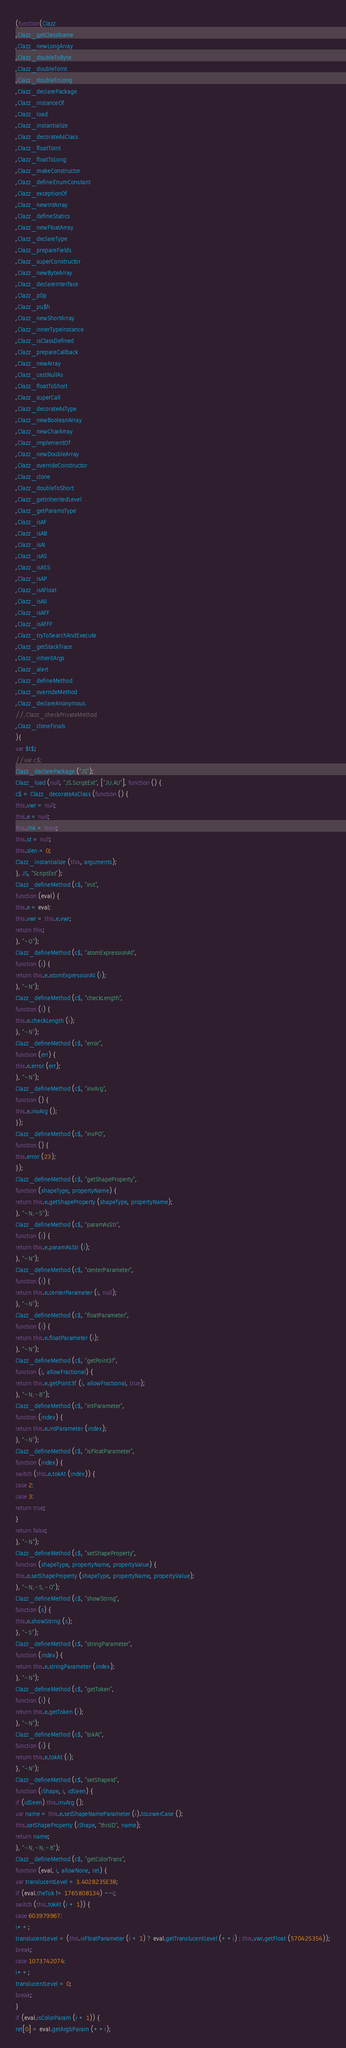Convert code to text. <code><loc_0><loc_0><loc_500><loc_500><_JavaScript_>(function(Clazz
,Clazz_getClassName
,Clazz_newLongArray
,Clazz_doubleToByte
,Clazz_doubleToInt
,Clazz_doubleToLong
,Clazz_declarePackage
,Clazz_instanceOf
,Clazz_load
,Clazz_instantialize
,Clazz_decorateAsClass
,Clazz_floatToInt
,Clazz_floatToLong
,Clazz_makeConstructor
,Clazz_defineEnumConstant
,Clazz_exceptionOf
,Clazz_newIntArray
,Clazz_defineStatics
,Clazz_newFloatArray
,Clazz_declareType
,Clazz_prepareFields
,Clazz_superConstructor
,Clazz_newByteArray
,Clazz_declareInterface
,Clazz_p0p
,Clazz_pu$h
,Clazz_newShortArray
,Clazz_innerTypeInstance
,Clazz_isClassDefined
,Clazz_prepareCallback
,Clazz_newArray
,Clazz_castNullAs
,Clazz_floatToShort
,Clazz_superCall
,Clazz_decorateAsType
,Clazz_newBooleanArray
,Clazz_newCharArray
,Clazz_implementOf
,Clazz_newDoubleArray
,Clazz_overrideConstructor
,Clazz_clone
,Clazz_doubleToShort
,Clazz_getInheritedLevel
,Clazz_getParamsType
,Clazz_isAF
,Clazz_isAB
,Clazz_isAI
,Clazz_isAS
,Clazz_isASS
,Clazz_isAP
,Clazz_isAFloat
,Clazz_isAII
,Clazz_isAFF
,Clazz_isAFFF
,Clazz_tryToSearchAndExecute
,Clazz_getStackTrace
,Clazz_inheritArgs
,Clazz_alert
,Clazz_defineMethod
,Clazz_overrideMethod
,Clazz_declareAnonymous
//,Clazz_checkPrivateMethod
,Clazz_cloneFinals
){
var $t$;
//var c$;
Clazz_declarePackage ("JS");
Clazz_load (null, "JS.ScriptExt", ["JU.AU"], function () {
c$ = Clazz_decorateAsClass (function () {
this.vwr = null;
this.e = null;
this.chk = false;
this.st = null;
this.slen = 0;
Clazz_instantialize (this, arguments);
}, JS, "ScriptExt");
Clazz_defineMethod (c$, "init", 
function (eval) {
this.e = eval;
this.vwr = this.e.vwr;
return this;
}, "~O");
Clazz_defineMethod (c$, "atomExpressionAt", 
function (i) {
return this.e.atomExpressionAt (i);
}, "~N");
Clazz_defineMethod (c$, "checkLength", 
function (i) {
this.e.checkLength (i);
}, "~N");
Clazz_defineMethod (c$, "error", 
function (err) {
this.e.error (err);
}, "~N");
Clazz_defineMethod (c$, "invArg", 
function () {
this.e.invArg ();
});
Clazz_defineMethod (c$, "invPO", 
function () {
this.error (23);
});
Clazz_defineMethod (c$, "getShapeProperty", 
function (shapeType, propertyName) {
return this.e.getShapeProperty (shapeType, propertyName);
}, "~N,~S");
Clazz_defineMethod (c$, "paramAsStr", 
function (i) {
return this.e.paramAsStr (i);
}, "~N");
Clazz_defineMethod (c$, "centerParameter", 
function (i) {
return this.e.centerParameter (i, null);
}, "~N");
Clazz_defineMethod (c$, "floatParameter", 
function (i) {
return this.e.floatParameter (i);
}, "~N");
Clazz_defineMethod (c$, "getPoint3f", 
function (i, allowFractional) {
return this.e.getPoint3f (i, allowFractional, true);
}, "~N,~B");
Clazz_defineMethod (c$, "intParameter", 
function (index) {
return this.e.intParameter (index);
}, "~N");
Clazz_defineMethod (c$, "isFloatParameter", 
function (index) {
switch (this.e.tokAt (index)) {
case 2:
case 3:
return true;
}
return false;
}, "~N");
Clazz_defineMethod (c$, "setShapeProperty", 
function (shapeType, propertyName, propertyValue) {
this.e.setShapeProperty (shapeType, propertyName, propertyValue);
}, "~N,~S,~O");
Clazz_defineMethod (c$, "showString", 
function (s) {
this.e.showString (s);
}, "~S");
Clazz_defineMethod (c$, "stringParameter", 
function (index) {
return this.e.stringParameter (index);
}, "~N");
Clazz_defineMethod (c$, "getToken", 
function (i) {
return this.e.getToken (i);
}, "~N");
Clazz_defineMethod (c$, "tokAt", 
function (i) {
return this.e.tokAt (i);
}, "~N");
Clazz_defineMethod (c$, "setShapeId", 
function (iShape, i, idSeen) {
if (idSeen) this.invArg ();
var name = this.e.setShapeNameParameter (i).toLowerCase ();
this.setShapeProperty (iShape, "thisID", name);
return name;
}, "~N,~N,~B");
Clazz_defineMethod (c$, "getColorTrans", 
function (eval, i, allowNone, ret) {
var translucentLevel = 3.4028235E38;
if (eval.theTok != 1765808134) --i;
switch (this.tokAt (i + 1)) {
case 603979967:
i++;
translucentLevel = (this.isFloatParameter (i + 1) ? eval.getTranslucentLevel (++i) : this.vwr.getFloat (570425354));
break;
case 1073742074:
i++;
translucentLevel = 0;
break;
}
if (eval.isColorParam (i + 1)) {
ret[0] = eval.getArgbParam (++i);</code> 